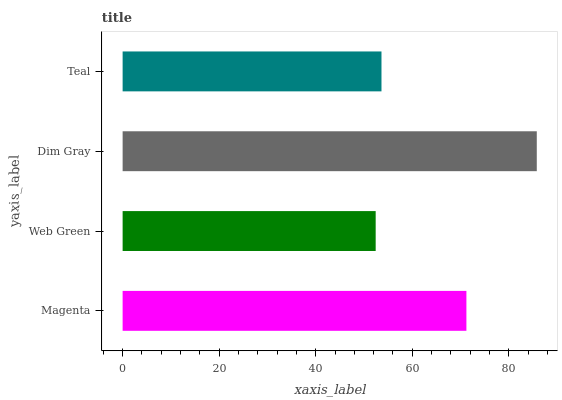Is Web Green the minimum?
Answer yes or no. Yes. Is Dim Gray the maximum?
Answer yes or no. Yes. Is Dim Gray the minimum?
Answer yes or no. No. Is Web Green the maximum?
Answer yes or no. No. Is Dim Gray greater than Web Green?
Answer yes or no. Yes. Is Web Green less than Dim Gray?
Answer yes or no. Yes. Is Web Green greater than Dim Gray?
Answer yes or no. No. Is Dim Gray less than Web Green?
Answer yes or no. No. Is Magenta the high median?
Answer yes or no. Yes. Is Teal the low median?
Answer yes or no. Yes. Is Teal the high median?
Answer yes or no. No. Is Dim Gray the low median?
Answer yes or no. No. 